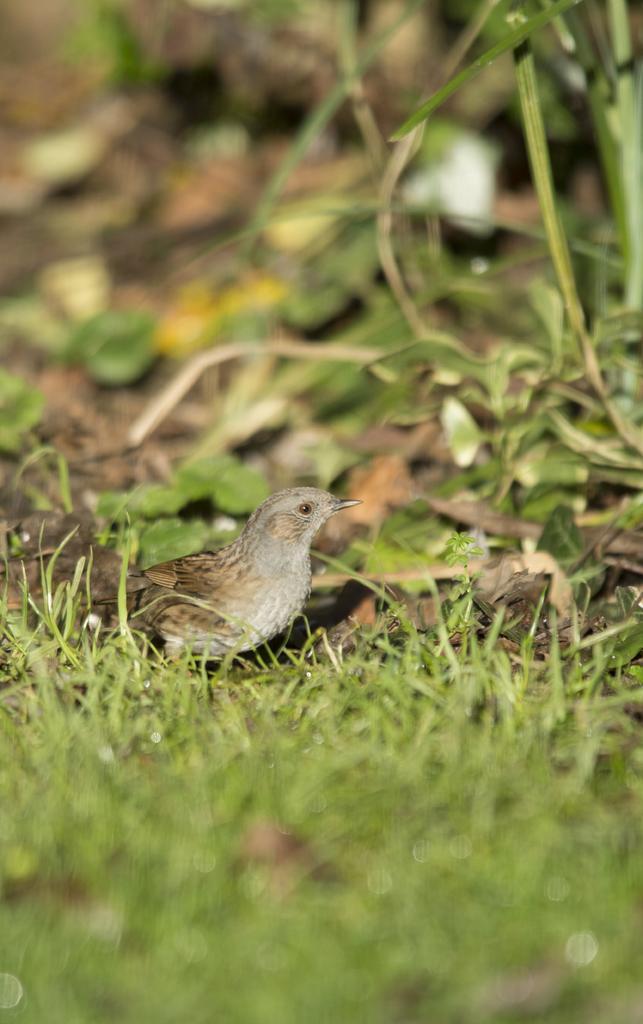Describe this image in one or two sentences. In this image in the front there's grass on the ground. In the center there is a bird. In the background there are leaves. 